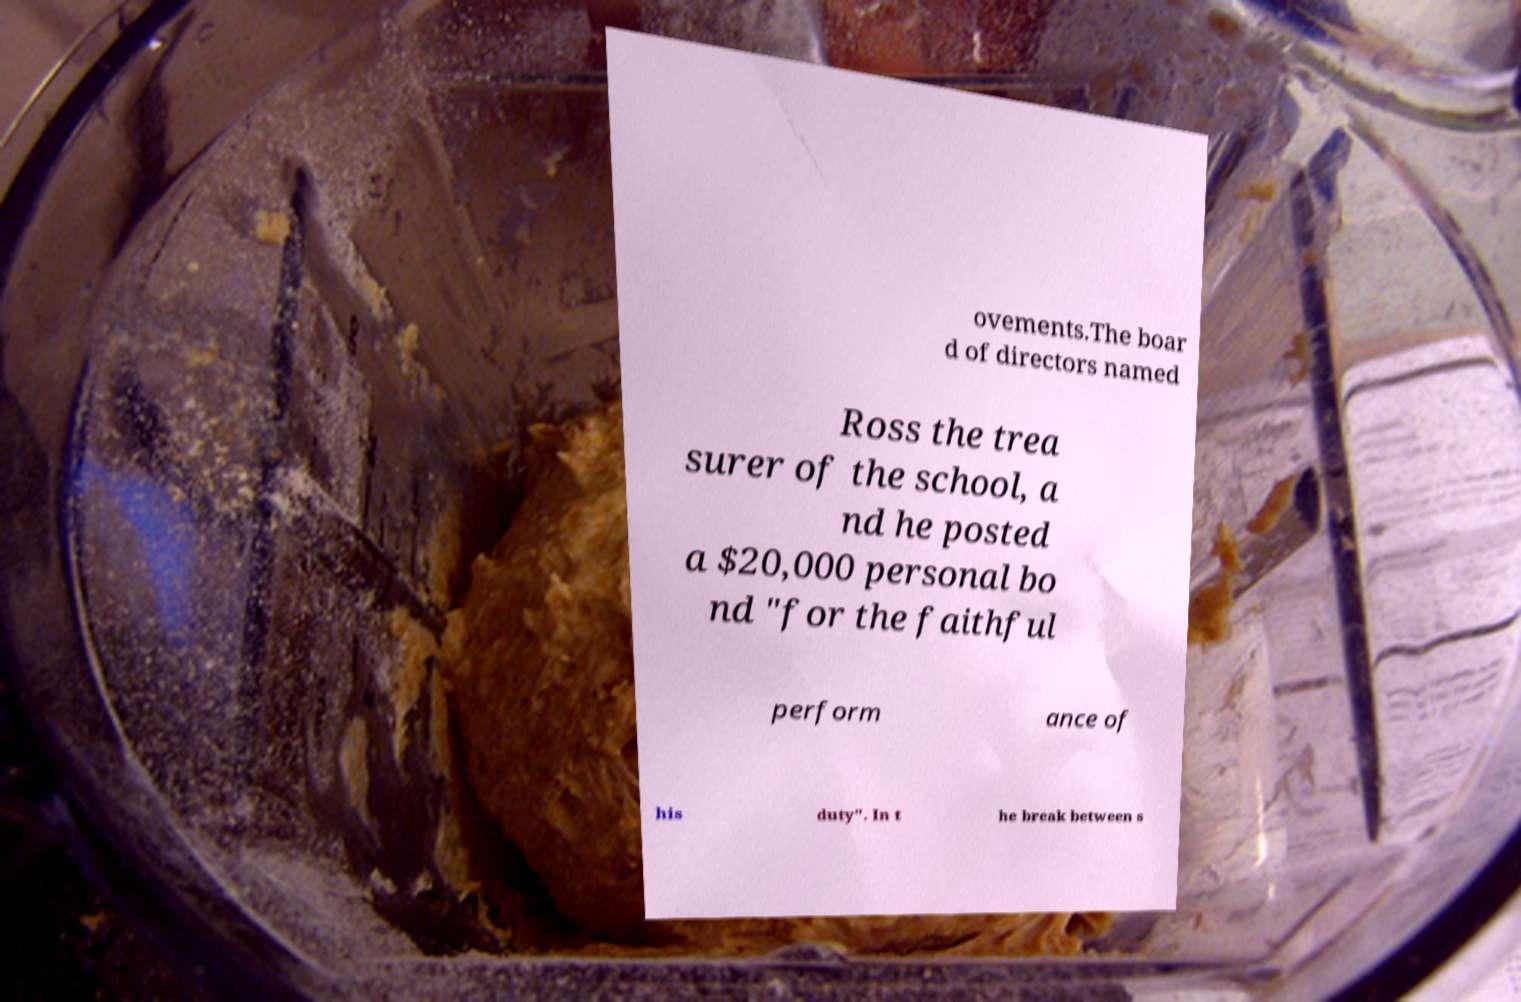Can you accurately transcribe the text from the provided image for me? ovements.The boar d of directors named Ross the trea surer of the school, a nd he posted a $20,000 personal bo nd "for the faithful perform ance of his duty". In t he break between s 